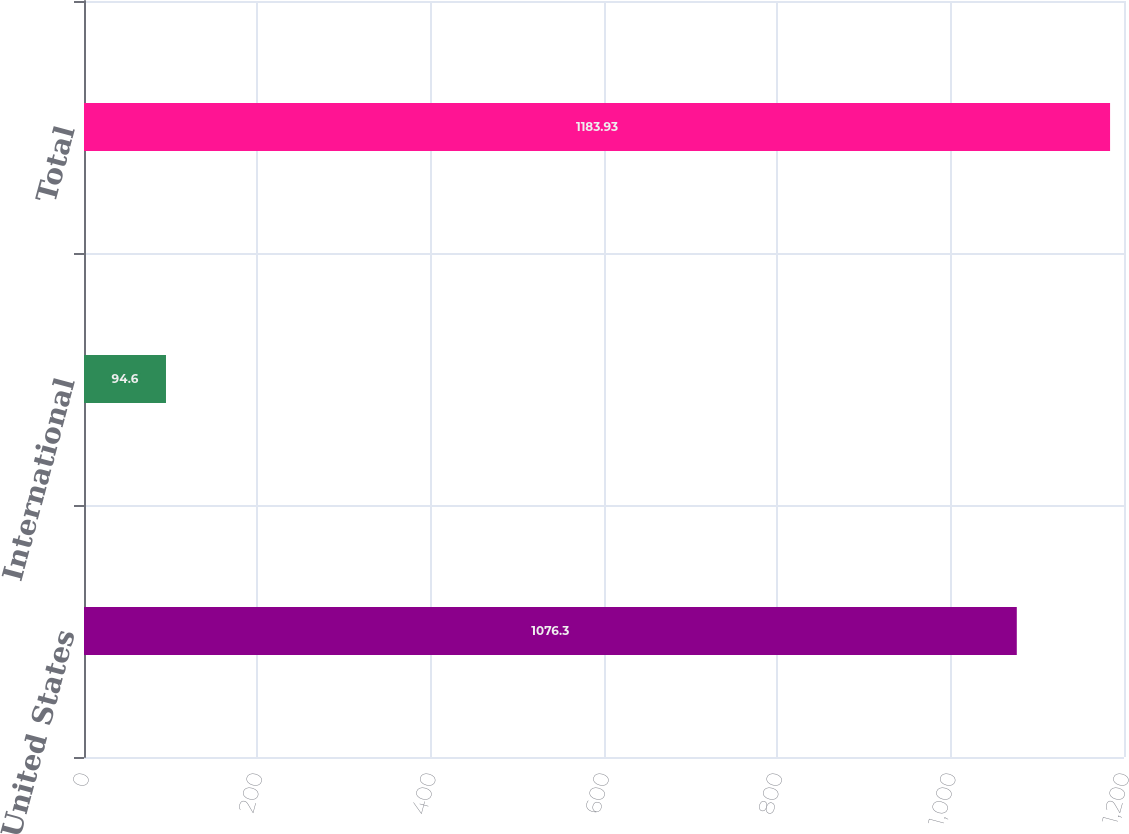<chart> <loc_0><loc_0><loc_500><loc_500><bar_chart><fcel>United States<fcel>International<fcel>Total<nl><fcel>1076.3<fcel>94.6<fcel>1183.93<nl></chart> 